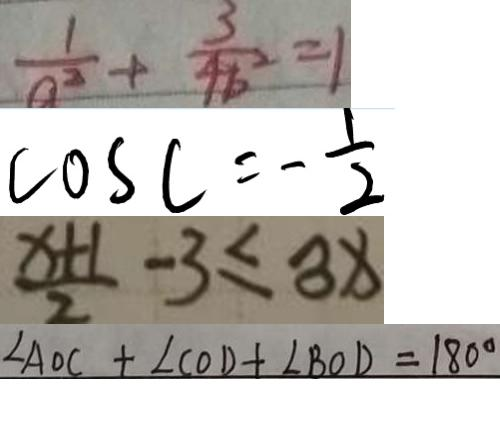Convert formula to latex. <formula><loc_0><loc_0><loc_500><loc_500>\frac { 1 } { a ^ { 2 } } + \frac { 3 } { 4 b ^ { 2 } } = 1 
 \cos C = - \frac { 1 } { 2 } 
 \frac { x + 1 } { 2 } - 3 \leq 3 x 
 \angle A O C + \angle C O D + \angle B O D = 1 8 0 ^ { \circ }</formula> 